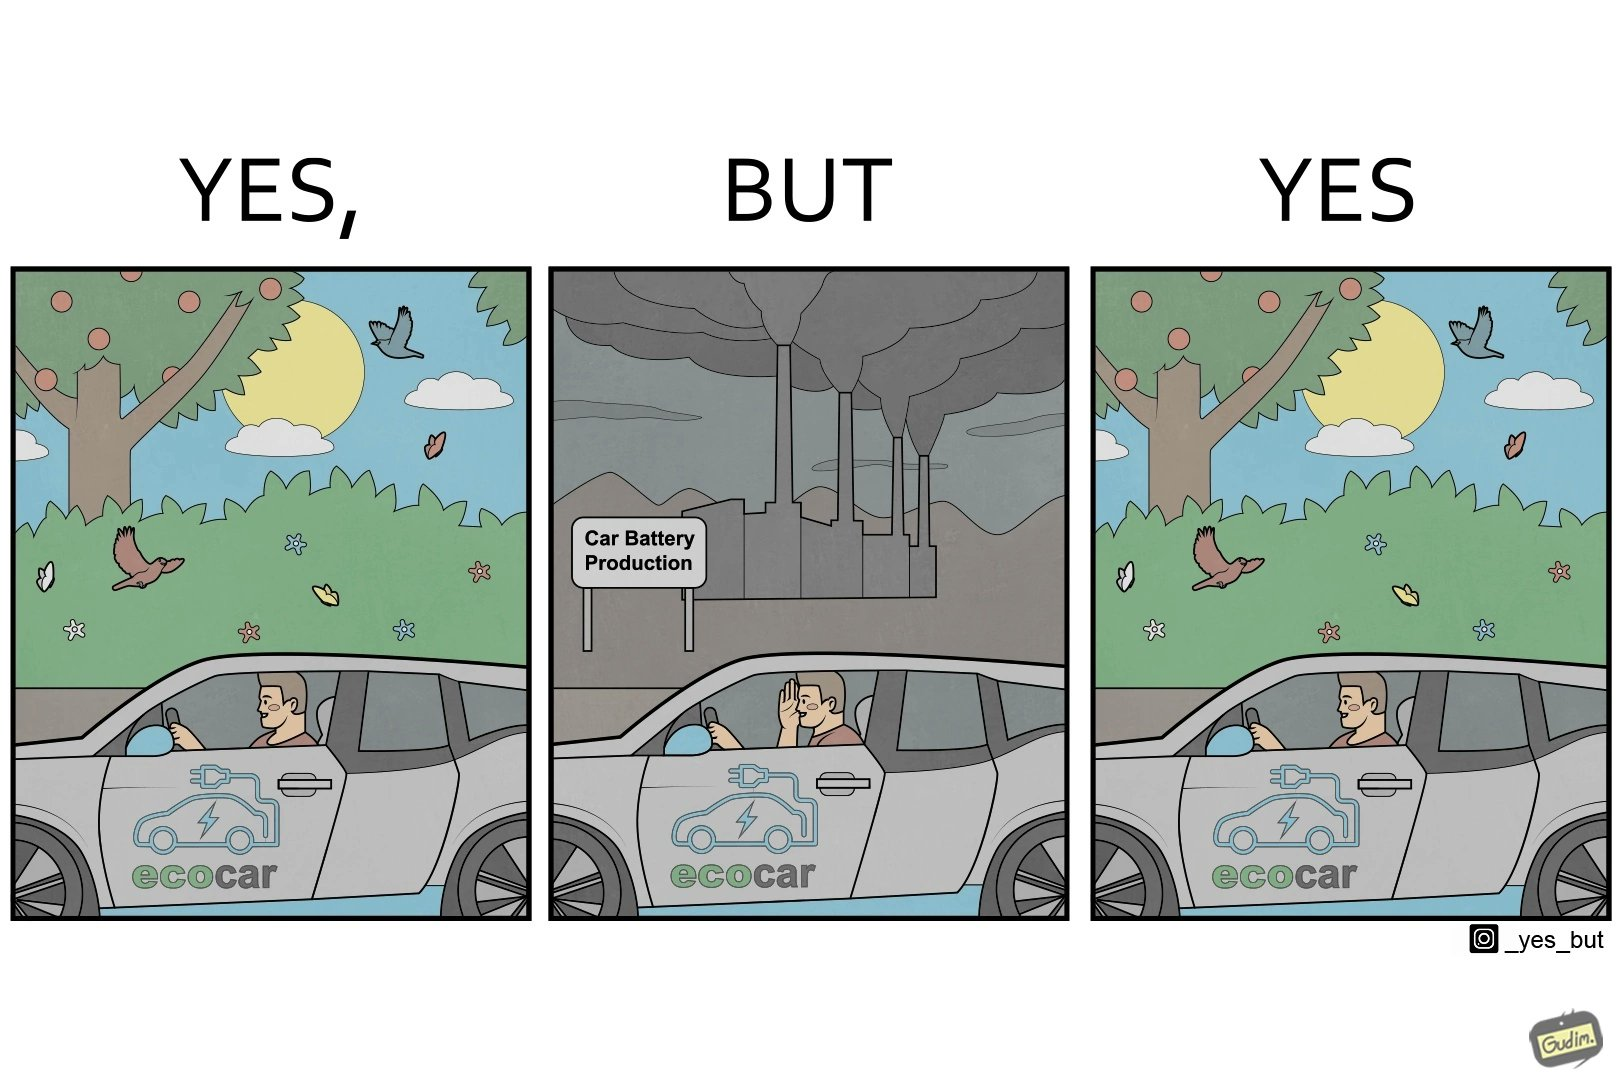What is shown in this image? The images are ironic since they show how even though electric powered cars are touted to be a game changer in the automotive industry and claims are made that they will make the world a greener and cleaner place to live in, the reality is quite different. Battery production causes vast amounts of pollution making such claims very doubtful 